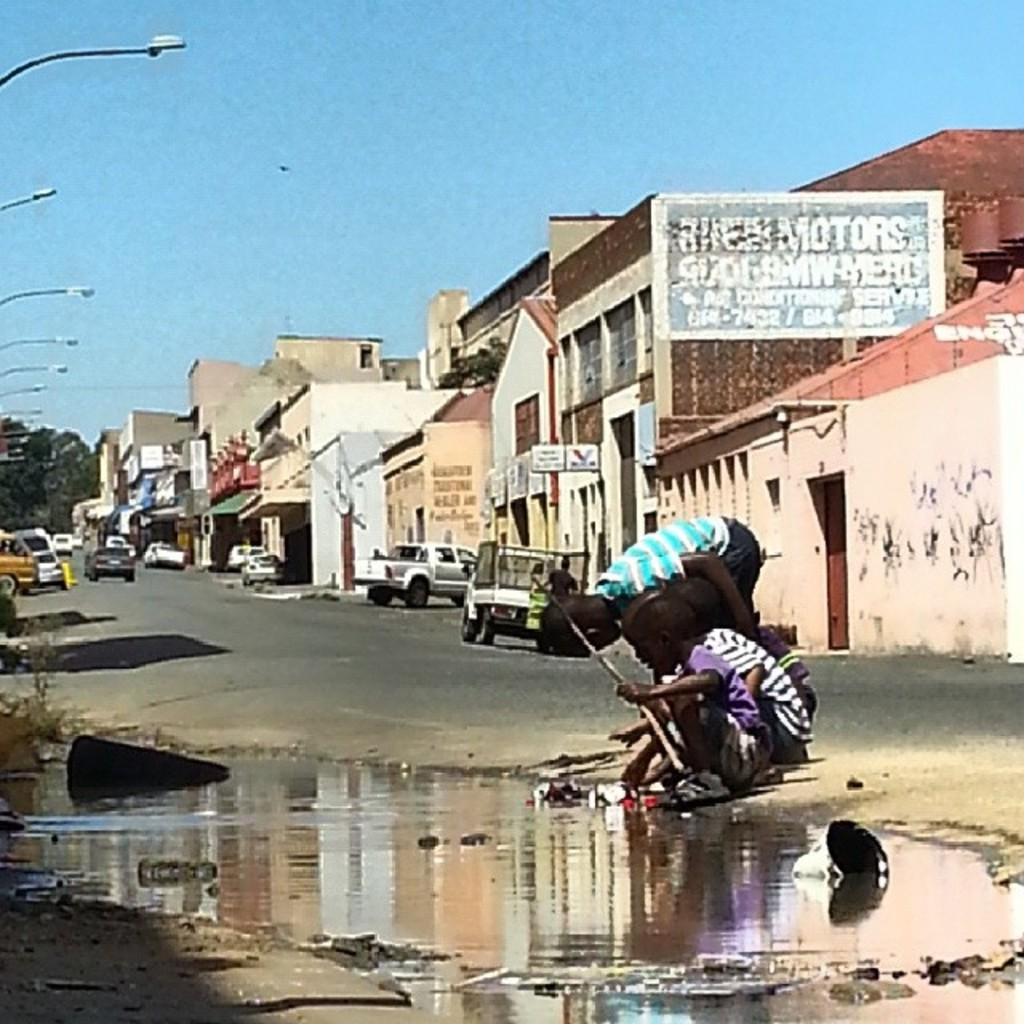What is located in the center of the image? There is water in the center of the image. What are the kids in the image holding? The kids in the image are holding objects. What can be seen in the background of the image? The sky, buildings, poles, trees, and banners are visible in the background of the image. Are there any vehicles visible in the background of the image? Yes, vehicles are visible in the background of the image. What type of wood can be seen in the image? There is no wood present in the image. Is there a trail visible in the image? There is no trail visible in the image. 